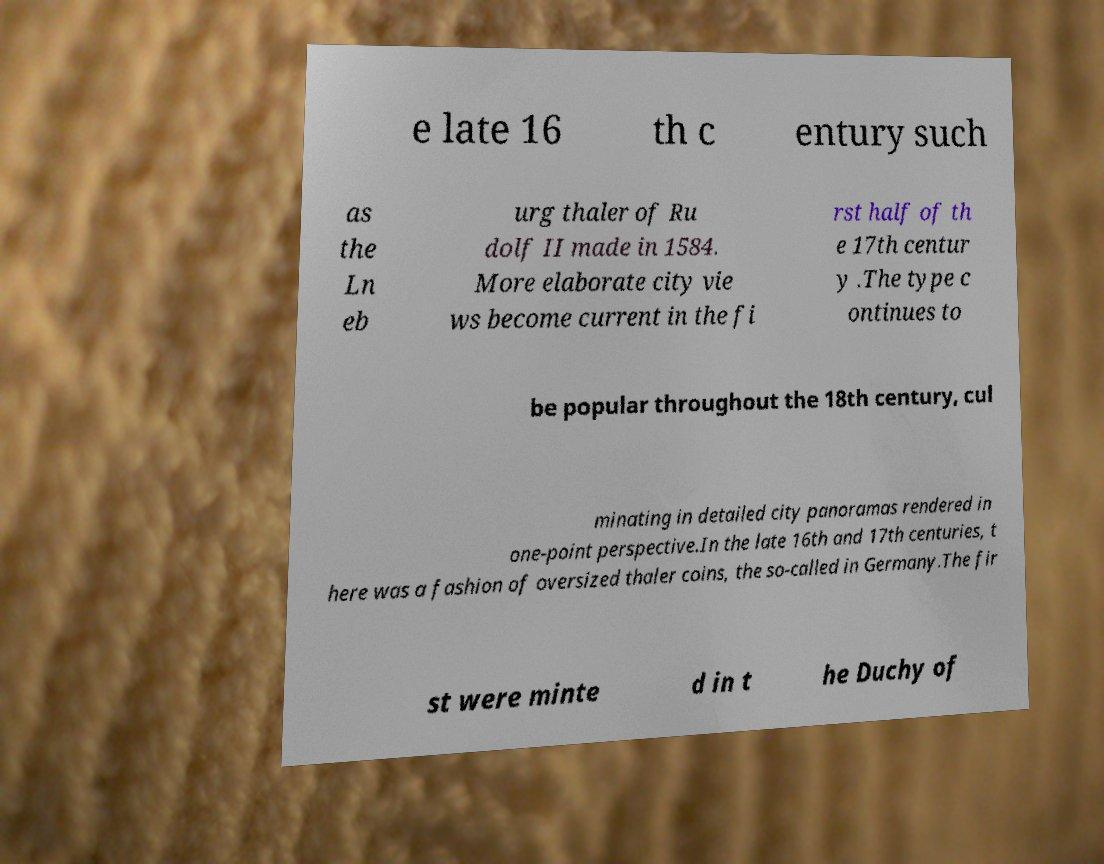There's text embedded in this image that I need extracted. Can you transcribe it verbatim? e late 16 th c entury such as the Ln eb urg thaler of Ru dolf II made in 1584. More elaborate city vie ws become current in the fi rst half of th e 17th centur y .The type c ontinues to be popular throughout the 18th century, cul minating in detailed city panoramas rendered in one-point perspective.In the late 16th and 17th centuries, t here was a fashion of oversized thaler coins, the so-called in Germany.The fir st were minte d in t he Duchy of 